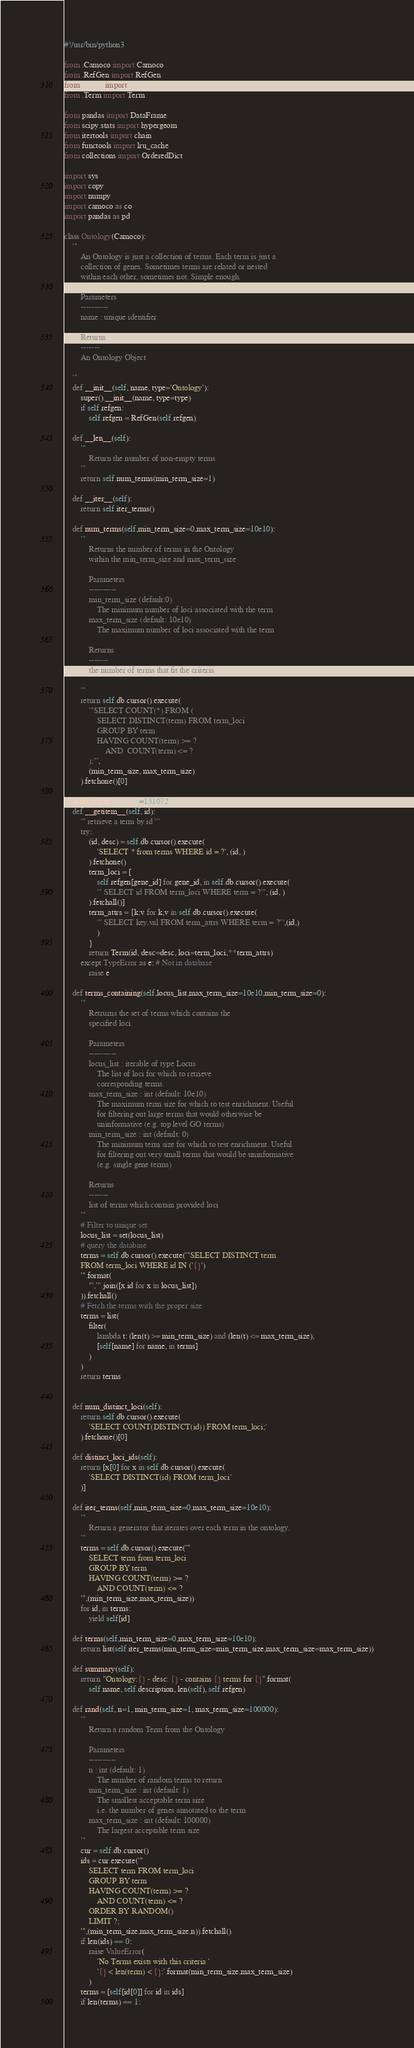Convert code to text. <code><loc_0><loc_0><loc_500><loc_500><_Python_>#!/usr/bin/python3

from .Camoco import Camoco
from .RefGen import RefGen
from .Locus import Locus
from .Term import Term

from pandas import DataFrame
from scipy.stats import hypergeom
from itertools import chain
from functools import lru_cache
from collections import OrderedDict

import sys
import copy
import numpy
import camoco as co
import pandas as pd

class Ontology(Camoco):
    '''
        An Ontology is just a collection of terms. Each term is just a
        collection of genes. Sometimes terms are related or nested
        within each other, sometimes not. Simple enough.
        
        Parameters
        ----------
        name : unique identifier

        Returns
        -------
        An Ontology Object

    '''
    def __init__(self, name, type='Ontology'):
        super().__init__(name, type=type)
        if self.refgen:
            self.refgen = RefGen(self.refgen)

    def __len__(self):
        '''
            Return the number of non-empty terms
        '''
        return self.num_terms(min_term_size=1)

    def __iter__(self):
        return self.iter_terms()

    def num_terms(self,min_term_size=0,max_term_size=10e10):
        '''
            Returns the number of terms in the Ontology
            within the min_term_size and max_term_size

            Parameters
            ----------
            min_term_size (default:0)
                The minimum number of loci associated with the term 
            max_term_size (default: 10e10)
                The maximum number of loci associated with the term

            Returns
            -------
            the number of terms that fit the criteria

        '''
        return self.db.cursor().execute(
            '''SELECT COUNT(*) FROM (
                SELECT DISTINCT(term) FROM term_loci 
                GROUP BY term 
                HAVING COUNT(term) >= ? 
                    AND  COUNT(term) <= ?
            );''',
            (min_term_size, max_term_size)
        ).fetchone()[0]

    @lru_cache(maxsize=131072)
    def __getitem__(self, id):
        ''' retrieve a term by id '''
        try:
            (id, desc) = self.db.cursor().execute(
                'SELECT * from terms WHERE id = ?', (id, )
            ).fetchone()
            term_loci = [
                self.refgen[gene_id] for gene_id, in self.db.cursor().execute(
                ''' SELECT id FROM term_loci WHERE term = ?''', (id, )
            ).fetchall()]
            term_attrs = {k:v for k,v in self.db.cursor().execute(
                ''' SELECT key,val FROM term_attrs WHERE term = ?''',(id,)         
                )
            }
            return Term(id, desc=desc, loci=term_loci,**term_attrs)
        except TypeError as e: # Not in database
            raise e

    def terms_containing(self,locus_list,max_term_size=10e10,min_term_size=0):
        '''
            Retrurns the set of terms which contains the 
            specified loci.

            Parameters
            ----------
            locus_list : iterable of type Locus
                The list of loci for which to retrieve 
                corresponding terms.
            max_term_size : int (default: 10e10)
                The maximum term size for which to test enrichment. Useful
                for filtering out large terms that would otherwise be 
                uninformative (e.g. top level GO terms)
            min_term_size : int (default: 0)
                The minimum term size for which to test enrichment. Useful
                for filtering out very small terms that would be uninformative
                (e.g. single gene terms)

            Returns
            -------
            list of terms which contain provided loci
        '''
        # Filter to unique set
        locus_list = set(locus_list)
        # query the database
        terms = self.db.cursor().execute('''SELECT DISTINCT term 
        FROM term_loci WHERE id IN ('{}')
        '''.format(
            "','".join([x.id for x in locus_list])
        )).fetchall()
        # Fetch the terms with the proper size
        terms = list(
            filter(
                lambda t: (len(t) >= min_term_size) and (len(t) <= max_term_size),
                [self[name] for name, in terms]
            )
        )
        return terms


    def num_distinct_loci(self):
        return self.db.cursor().execute(
            'SELECT COUNT(DISTINCT(id)) FROM term_loci;'
        ).fetchone()[0]

    def distinct_loci_ids(self):
        return [x[0] for x in self.db.cursor().execute(
            'SELECT DISTINCT(id) FROM term_loci'
        )]

    def iter_terms(self,min_term_size=0,max_term_size=10e10):
        '''
            Return a generator that iterates over each term in the ontology.
        '''
        terms = self.db.cursor().execute('''
            SELECT term from term_loci
            GROUP BY term
            HAVING COUNT(term) >= ?
                AND COUNT(term) <= ?
        ''',(min_term_size,max_term_size))
        for id, in terms:
            yield self[id]

    def terms(self,min_term_size=0,max_term_size=10e10):
        return list(self.iter_terms(min_term_size=min_term_size,max_term_size=max_term_size))

    def summary(self):
        return "Ontology:{} - desc: {} - contains {} terms for {}".format(
            self.name, self.description, len(self), self.refgen)

    def rand(self, n=1, min_term_size=1, max_term_size=100000):
        '''
            Return a random Term from the Ontology

            Parameters
            ----------
            n : int (default: 1)
                The number of random terms to return
            min_term_size : int (default: 1)
                The smallest acceptable term size
                i.e. the number of genes annotated to the term
            max_term_size : int (default: 100000)
                The largest acceptable term size
        '''
        cur = self.db.cursor()
        ids = cur.execute(''' 
            SELECT term FROM term_loci 
            GROUP BY term 
            HAVING COUNT(term) >= ?
                AND COUNT(term) <= ?
            ORDER BY RANDOM() 
            LIMIT ?;
        ''',(min_term_size,max_term_size,n)).fetchall()
        if len(ids) == 0:
            raise ValueError(
                'No Terms exists with this criteria '
                '{} < len(term) < {}:'.format(min_term_size,max_term_size)
            )
        terms = [self[id[0]] for id in ids]
        if len(terms) == 1:</code> 